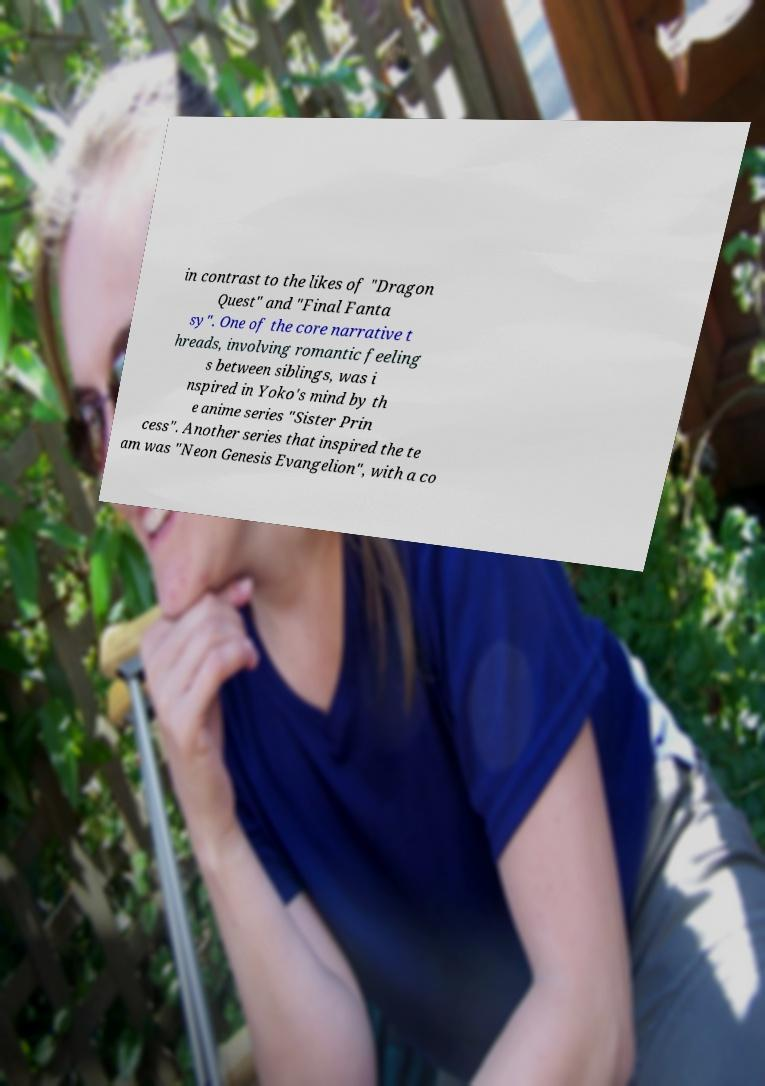Please identify and transcribe the text found in this image. in contrast to the likes of "Dragon Quest" and "Final Fanta sy". One of the core narrative t hreads, involving romantic feeling s between siblings, was i nspired in Yoko's mind by th e anime series "Sister Prin cess". Another series that inspired the te am was "Neon Genesis Evangelion", with a co 